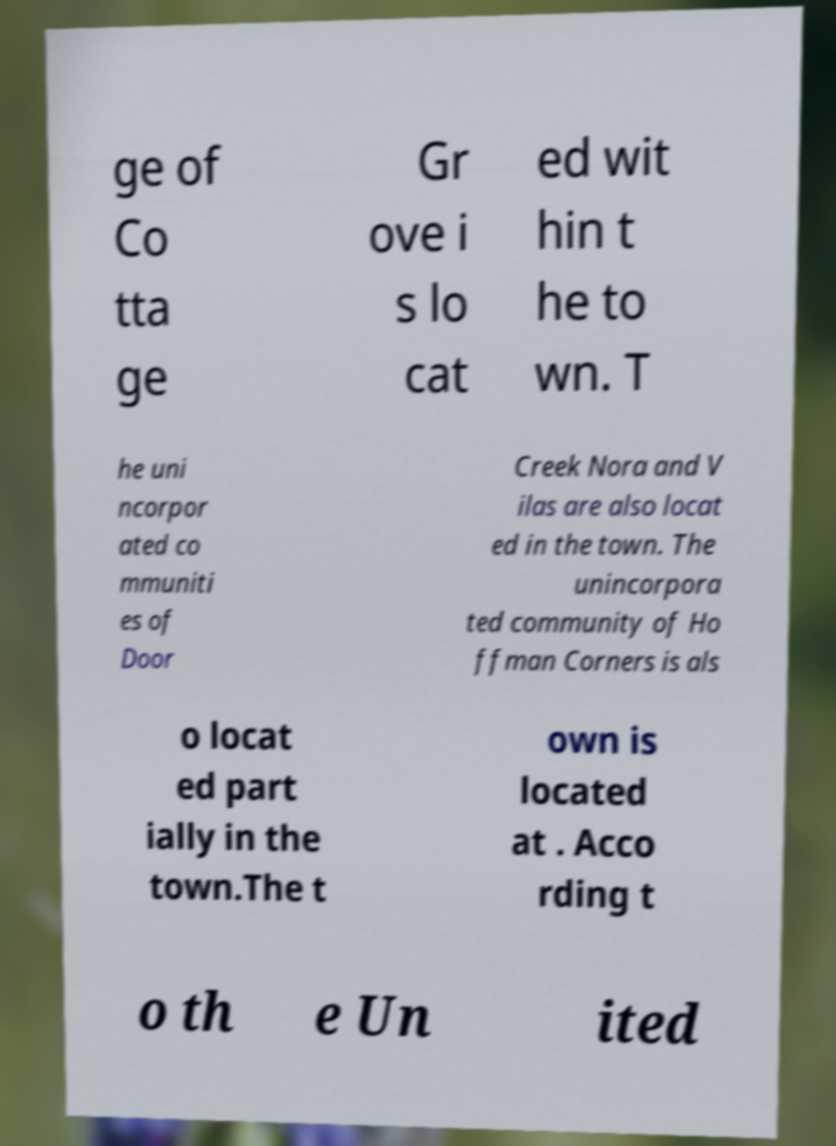Can you read and provide the text displayed in the image?This photo seems to have some interesting text. Can you extract and type it out for me? ge of Co tta ge Gr ove i s lo cat ed wit hin t he to wn. T he uni ncorpor ated co mmuniti es of Door Creek Nora and V ilas are also locat ed in the town. The unincorpora ted community of Ho ffman Corners is als o locat ed part ially in the town.The t own is located at . Acco rding t o th e Un ited 